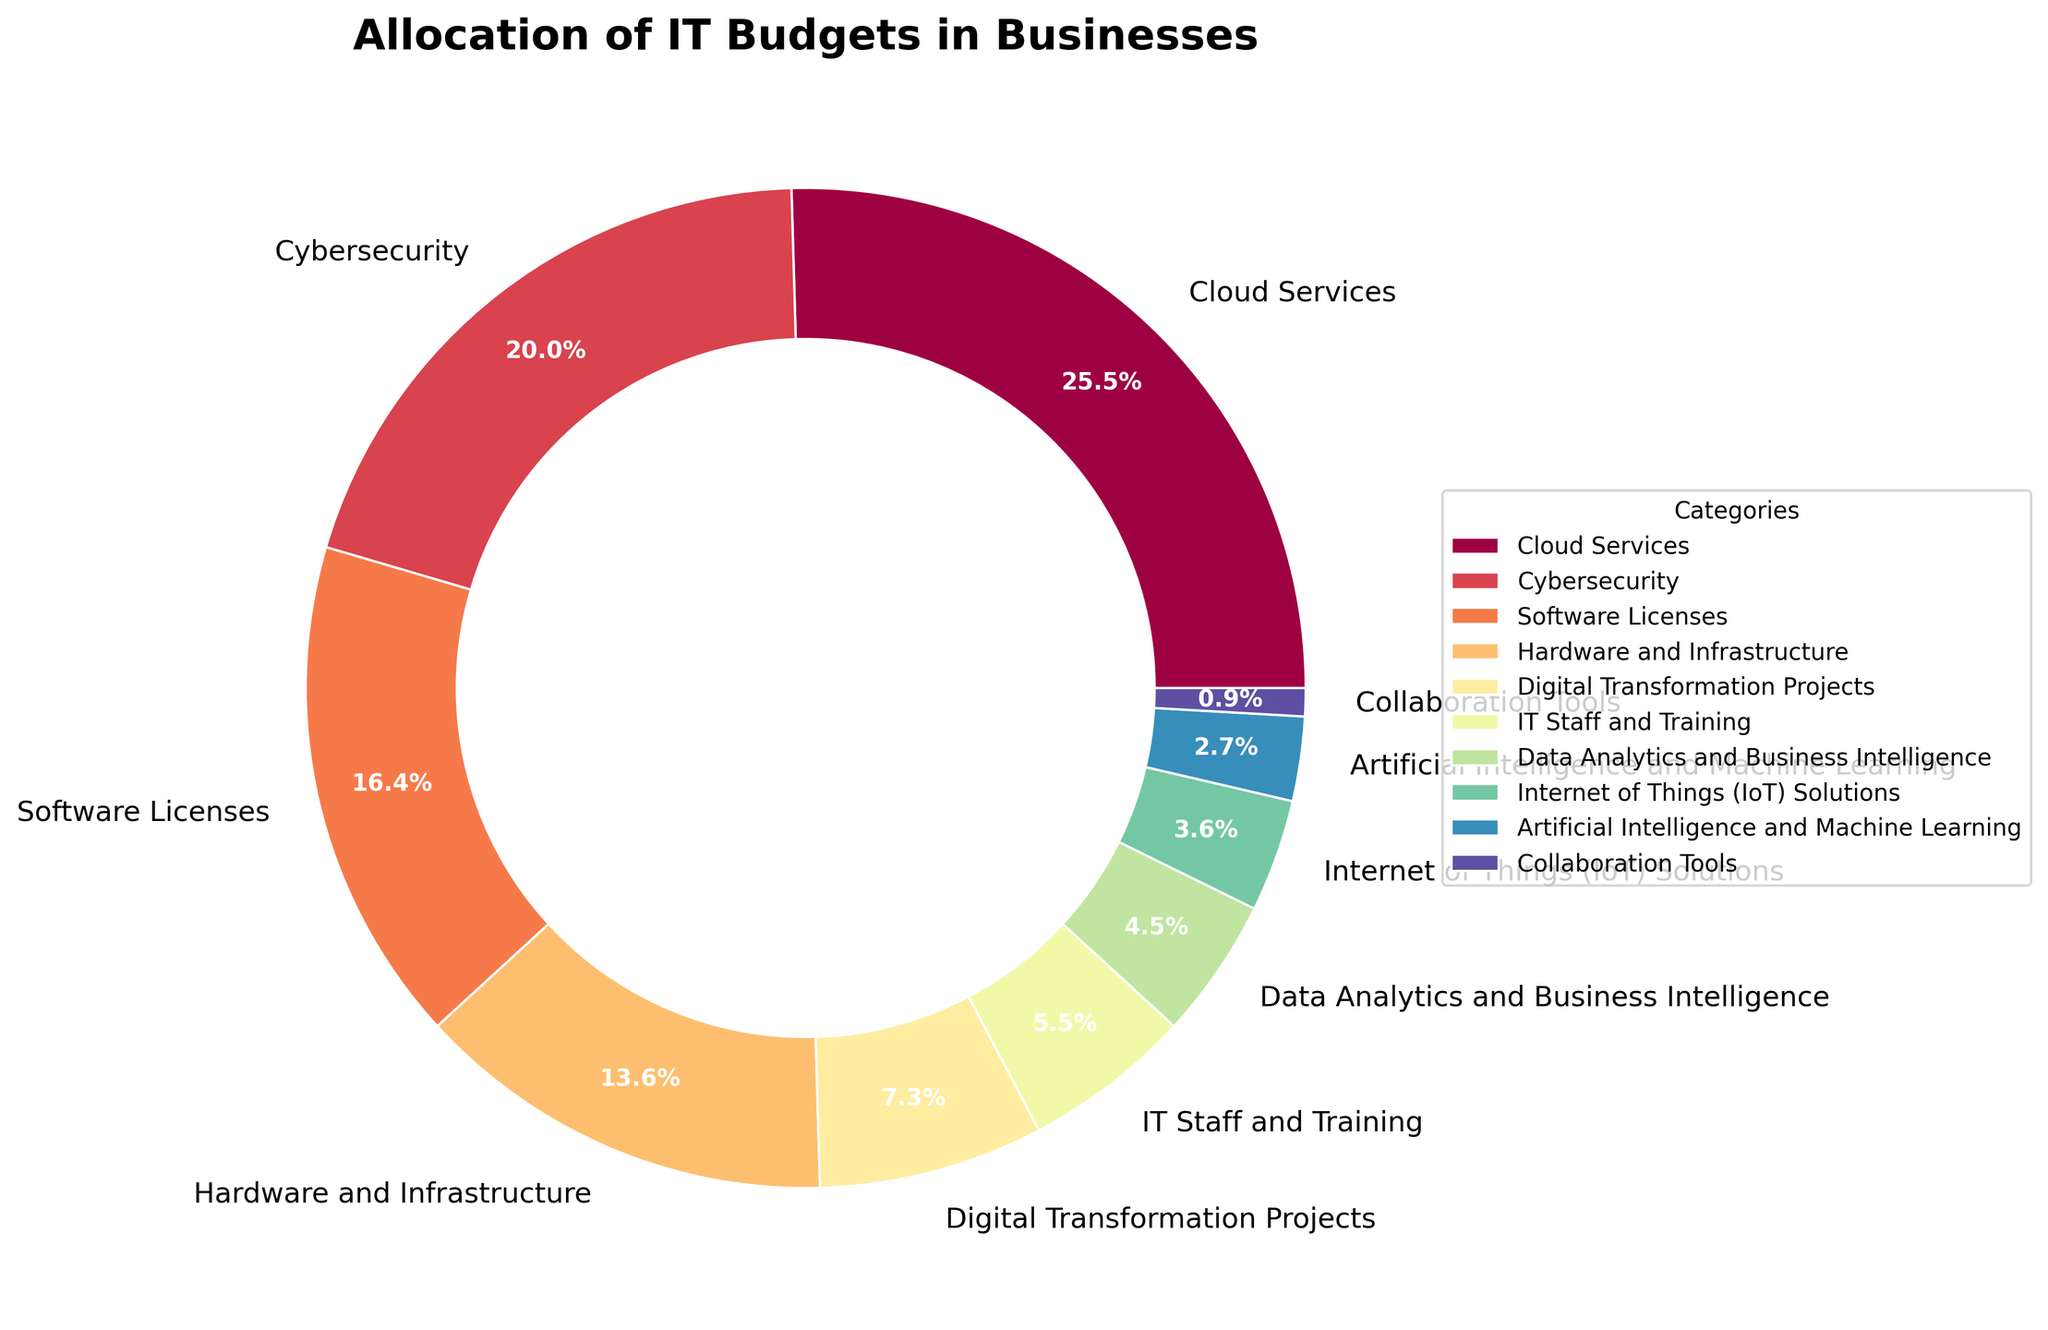What's the category with the largest allocation of IT budgets? Look at the figure and identify the category with the largest segment in the pie chart. It is marked as "Cloud Services" with the largest percentage (28%).
Answer: Cloud Services How much more is allocated to Cybersecurity than to Software Licenses? Compare the percentages allocated to Cybersecurity (22%) and Software Licenses (18%). Calculate the difference: 22% - 18% = 4%.
Answer: 4% What is the total percentage allocated to Digital Transformation Projects, IT Staff and Training, and Data Analytics and Business Intelligence combined? Sum the percentages for Digital Transformation Projects (8%), IT Staff and Training (6%), and Data Analytics and Business Intelligence (5%). 8% + 6% + 5% = 19%.
Answer: 19% Which has a smaller budget allocation: Internet of Things (IoT) Solutions or Artificial Intelligence and Machine Learning? Compare the percentages of Internet of Things (IoT) Solutions (4%) and Artificial Intelligence and Machine Learning (3%). The latter is smaller.
Answer: Artificial Intelligence and Machine Learning What percentage is allocated to categories not explicitly mentioned in the legend? Sum the percentages of all mentioned categories: 28% + 22% + 18% + 15% + 8% + 6% + 5% + 4% + 3% + 1% = 110%. Since the total should be 100%, there is no budget unaccounted for in the legend.
Answer: 0% Which category occupies the smallest segment visually in the pie chart? Identify the smallest segment in the pie chart, which is "Collaboration Tools" with 1%.
Answer: Collaboration Tools What is the combined allocation percentage for Cloud Services, Cybersecurity, and Software Licenses? Sum the percentages for Cloud Services (28%), Cybersecurity (22%), and Software Licenses (18%). 28% + 22% + 18% = 68%.
Answer: 68% How much less is allocated to Hardware and Infrastructure compared to Cloud Services? Compare the percentages allocated to Hardware and Infrastructure (15%) and Cloud Services (28%). Calculate the difference: 28% - 15% = 13%.
Answer: 13% What categories together make up less than 10% of the total IT budget? Identify categories with a percentage less than 10%. These include IT Staff and Training (6%), Data Analytics and Business Intelligence (5%), Internet of Things (IoT) Solutions (4%), Artificial Intelligence and Machine Learning (3%), and Collaboration Tools (1%).
Answer: IT Staff and Training, Data Analytics and Business Intelligence, Internet of Things (IoT) Solutions, Artificial Intelligence and Machine Learning, Collaboration Tools 